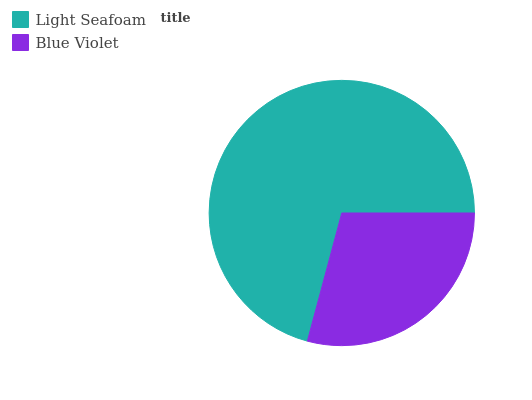Is Blue Violet the minimum?
Answer yes or no. Yes. Is Light Seafoam the maximum?
Answer yes or no. Yes. Is Blue Violet the maximum?
Answer yes or no. No. Is Light Seafoam greater than Blue Violet?
Answer yes or no. Yes. Is Blue Violet less than Light Seafoam?
Answer yes or no. Yes. Is Blue Violet greater than Light Seafoam?
Answer yes or no. No. Is Light Seafoam less than Blue Violet?
Answer yes or no. No. Is Light Seafoam the high median?
Answer yes or no. Yes. Is Blue Violet the low median?
Answer yes or no. Yes. Is Blue Violet the high median?
Answer yes or no. No. Is Light Seafoam the low median?
Answer yes or no. No. 